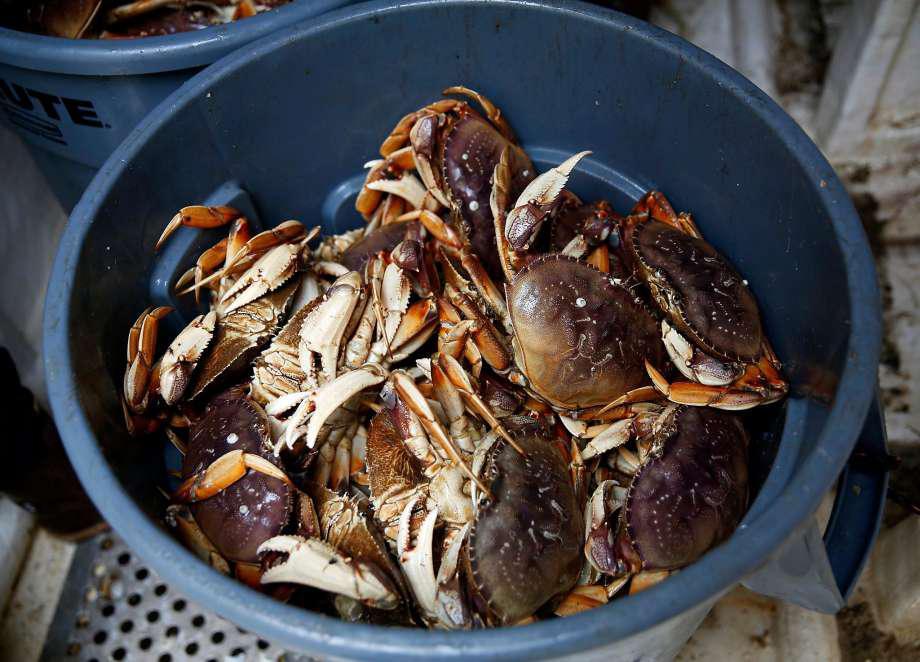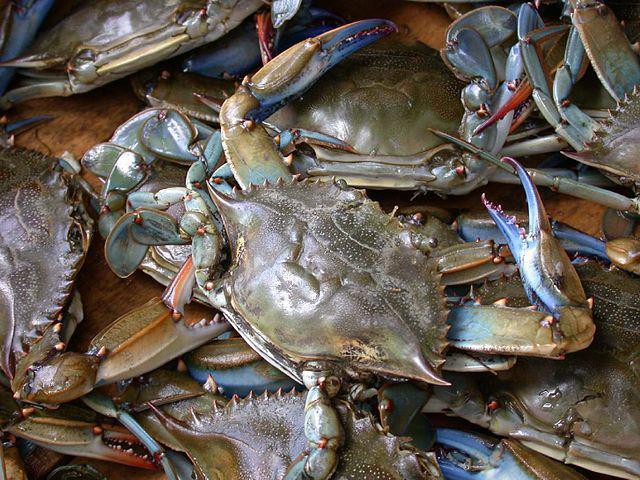The first image is the image on the left, the second image is the image on the right. Considering the images on both sides, is "One image shows a pile of shell-side up crabs without a container, and the other image shows a mass of crabs in a round container." valid? Answer yes or no. Yes. The first image is the image on the left, the second image is the image on the right. Examine the images to the left and right. Is the description "The crabs in one of the images are being weighed with a scale." accurate? Answer yes or no. No. 